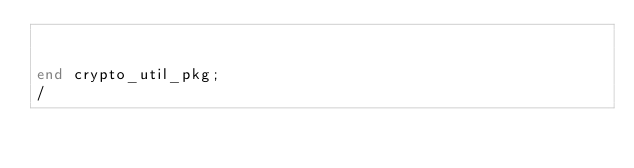<code> <loc_0><loc_0><loc_500><loc_500><_SQL_>

end crypto_util_pkg;
/

</code> 